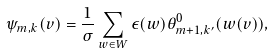Convert formula to latex. <formula><loc_0><loc_0><loc_500><loc_500>\psi _ { m , k } ( v ) = \frac { 1 } { \sigma } \sum _ { w \in W } \epsilon ( w ) \theta ^ { 0 } _ { m + 1 , k ^ { \prime } } ( w ( v ) ) ,</formula> 